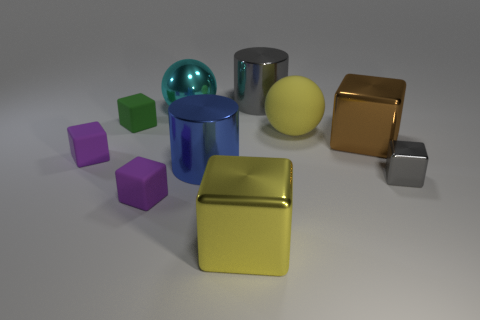Subtract all gray cubes. How many cubes are left? 5 Subtract all green spheres. How many purple cubes are left? 2 Subtract all purple blocks. How many blocks are left? 4 Subtract all brown cubes. Subtract all gray balls. How many cubes are left? 5 Add 5 brown objects. How many brown objects are left? 6 Add 3 blocks. How many blocks exist? 9 Subtract 0 cyan cubes. How many objects are left? 10 Subtract all cubes. How many objects are left? 4 Subtract all large purple shiny objects. Subtract all tiny metallic blocks. How many objects are left? 9 